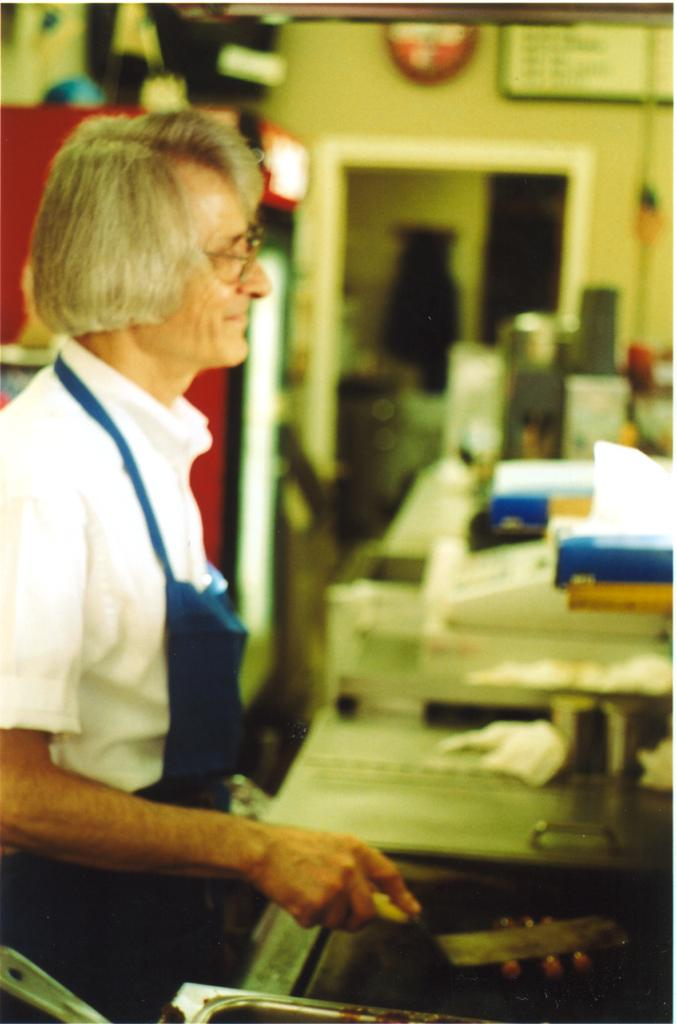Who or what is on the left side of the image? There is a person on the left side of the image. What is the person doing in the image? The person is standing in front of a desk. What can be seen on the desk in the image? There are objects placed on the desk. What is visible behind the person in the image? There is a wall in the background of the image. What type of riddle is the person solving in the image? There is no riddle present in the image; the person is simply standing in front of a desk with objects on it. 